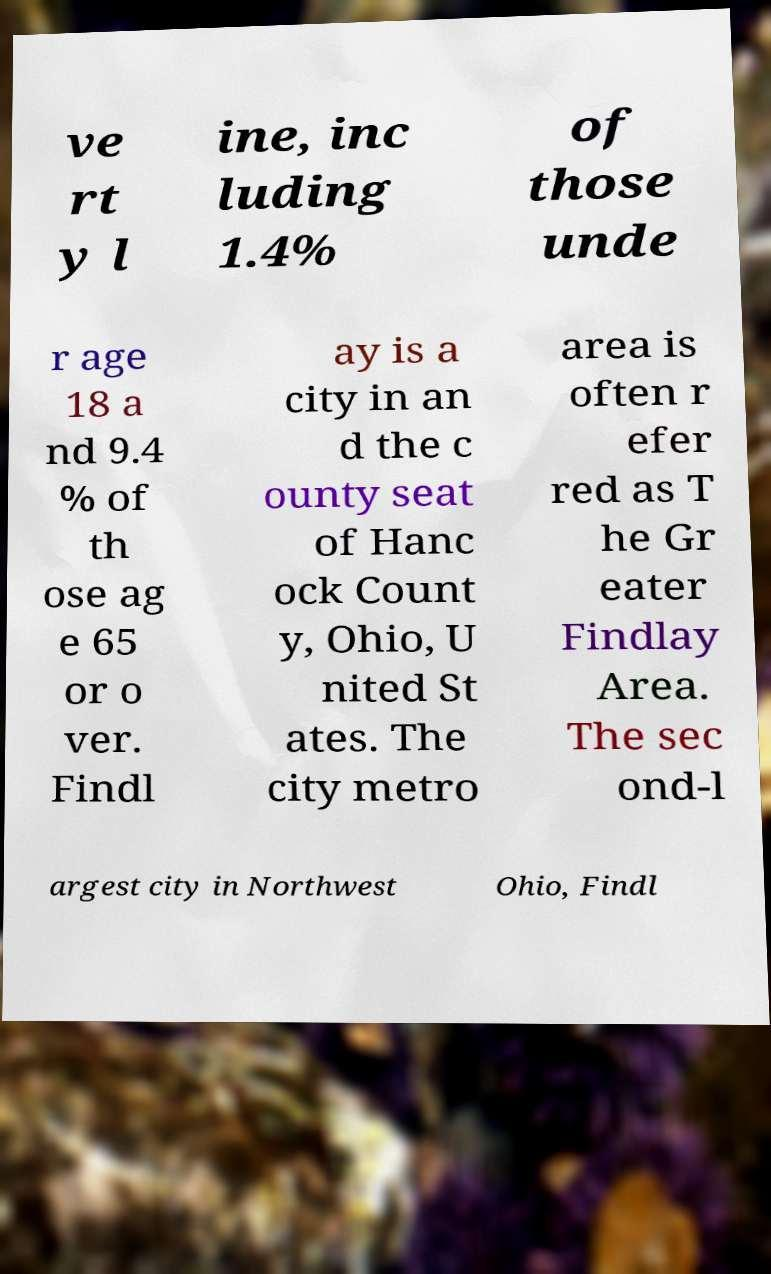What messages or text are displayed in this image? I need them in a readable, typed format. ve rt y l ine, inc luding 1.4% of those unde r age 18 a nd 9.4 % of th ose ag e 65 or o ver. Findl ay is a city in an d the c ounty seat of Hanc ock Count y, Ohio, U nited St ates. The city metro area is often r efer red as T he Gr eater Findlay Area. The sec ond-l argest city in Northwest Ohio, Findl 